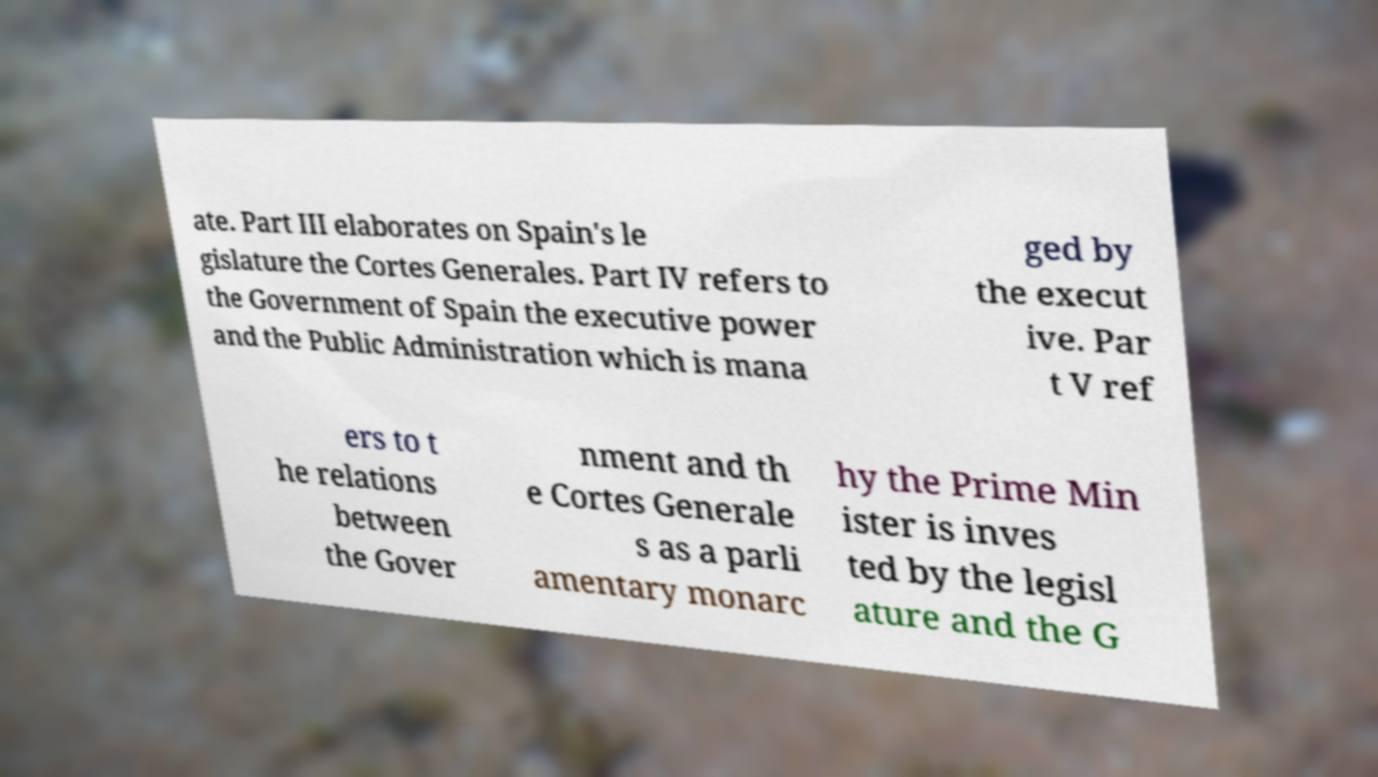There's text embedded in this image that I need extracted. Can you transcribe it verbatim? ate. Part III elaborates on Spain's le gislature the Cortes Generales. Part IV refers to the Government of Spain the executive power and the Public Administration which is mana ged by the execut ive. Par t V ref ers to t he relations between the Gover nment and th e Cortes Generale s as a parli amentary monarc hy the Prime Min ister is inves ted by the legisl ature and the G 